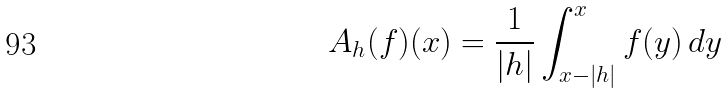Convert formula to latex. <formula><loc_0><loc_0><loc_500><loc_500>A _ { h } ( f ) ( x ) = \frac { 1 } { | h | } \int _ { x - | h | } ^ { x } f ( y ) \, d y</formula> 